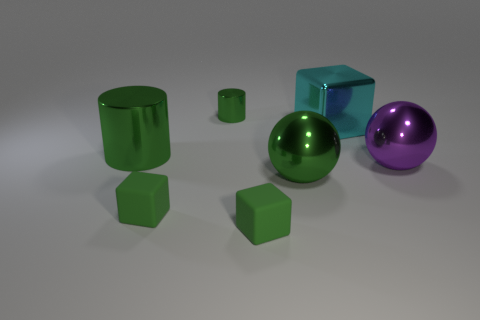Subtract all cyan cylinders. How many green cubes are left? 2 Subtract all small green rubber cubes. How many cubes are left? 1 Add 2 red metal cubes. How many objects exist? 9 Subtract all large green cylinders. Subtract all matte things. How many objects are left? 4 Add 7 big metallic cylinders. How many big metallic cylinders are left? 8 Add 2 large purple objects. How many large purple objects exist? 3 Subtract 0 brown balls. How many objects are left? 7 Subtract all cylinders. How many objects are left? 5 